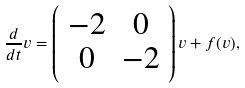<formula> <loc_0><loc_0><loc_500><loc_500>\frac { d } { d t } v = \left ( \begin{array} { c c } - 2 & 0 \\ 0 & - 2 \\ \end{array} \right ) v + f ( v ) ,</formula> 